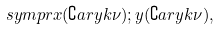<formula> <loc_0><loc_0><loc_500><loc_500>\ s y m p { r } { x ( \complement a r y { k } { \nu } ) ; y ( \complement a r y { k } { \nu } ) } ,</formula> 